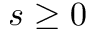Convert formula to latex. <formula><loc_0><loc_0><loc_500><loc_500>s \geq 0</formula> 